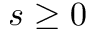Convert formula to latex. <formula><loc_0><loc_0><loc_500><loc_500>s \geq 0</formula> 